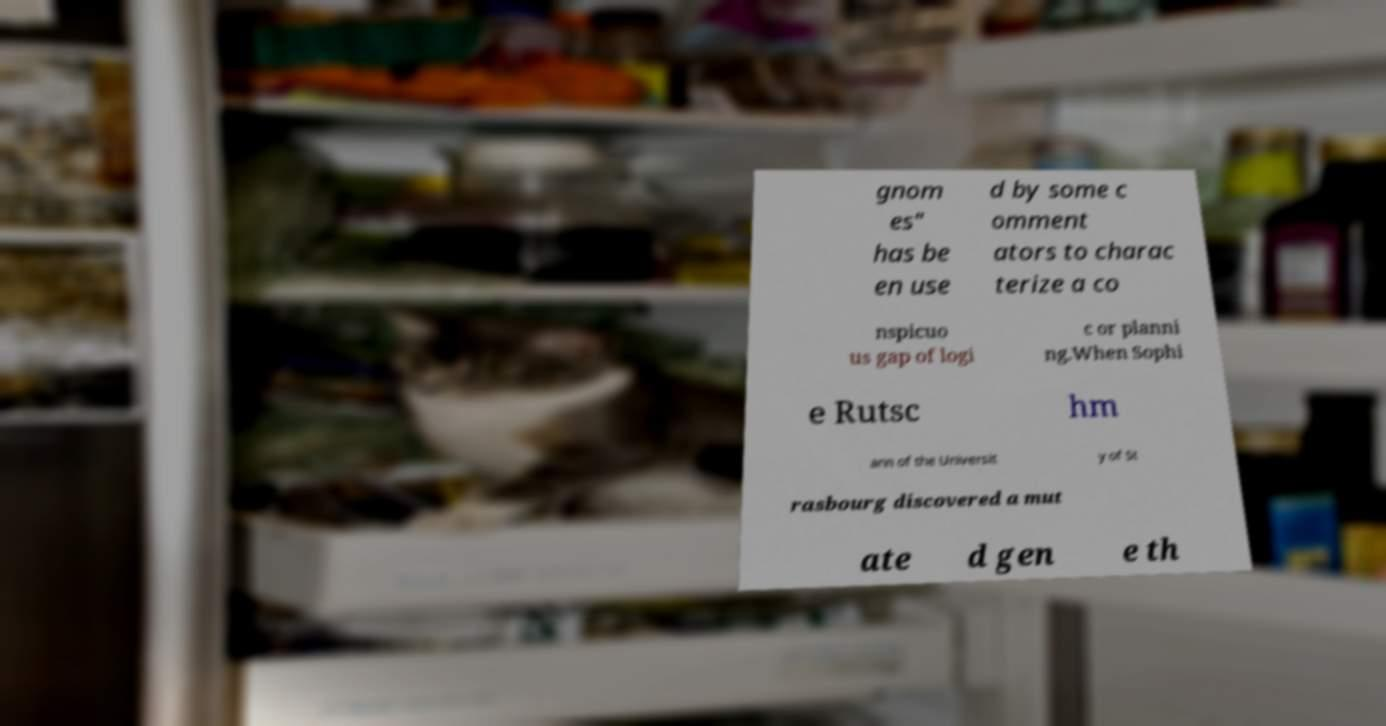I need the written content from this picture converted into text. Can you do that? gnom es" has be en use d by some c omment ators to charac terize a co nspicuo us gap of logi c or planni ng.When Sophi e Rutsc hm ann of the Universit y of St rasbourg discovered a mut ate d gen e th 